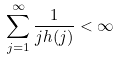<formula> <loc_0><loc_0><loc_500><loc_500>\sum _ { j = 1 } ^ { \infty } \frac { 1 } { j h ( j ) } < \infty</formula> 